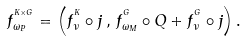Convert formula to latex. <formula><loc_0><loc_0><loc_500><loc_500>f ^ { ^ { K \times G } } _ { \omega _ { P } } = \left ( f ^ { ^ { K } } _ { \nu } \circ j \, , \, f ^ { ^ { G } } _ { \omega _ { M } } \circ Q + f ^ { ^ { G } } _ { \nu } \circ j \right ) .</formula> 